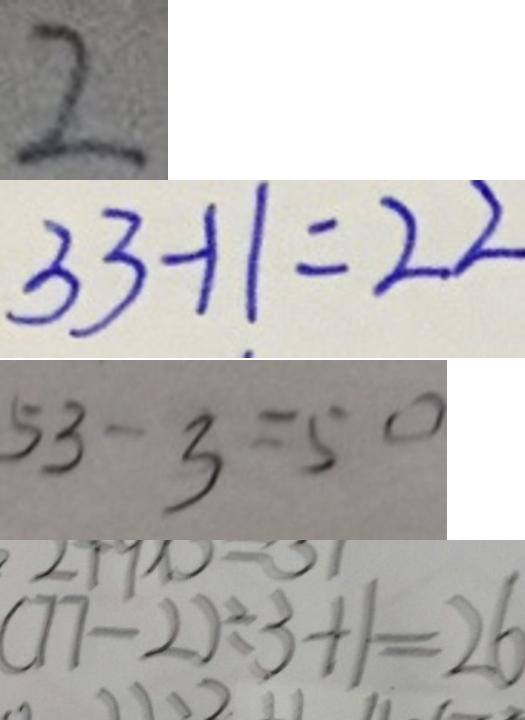<formula> <loc_0><loc_0><loc_500><loc_500>2 
 3 3 - 1 1 = 2 2 
 5 3 - 3 = 5 0 
 ( 7 7 - 2 ) \div 3 + 1 = 2 6</formula> 